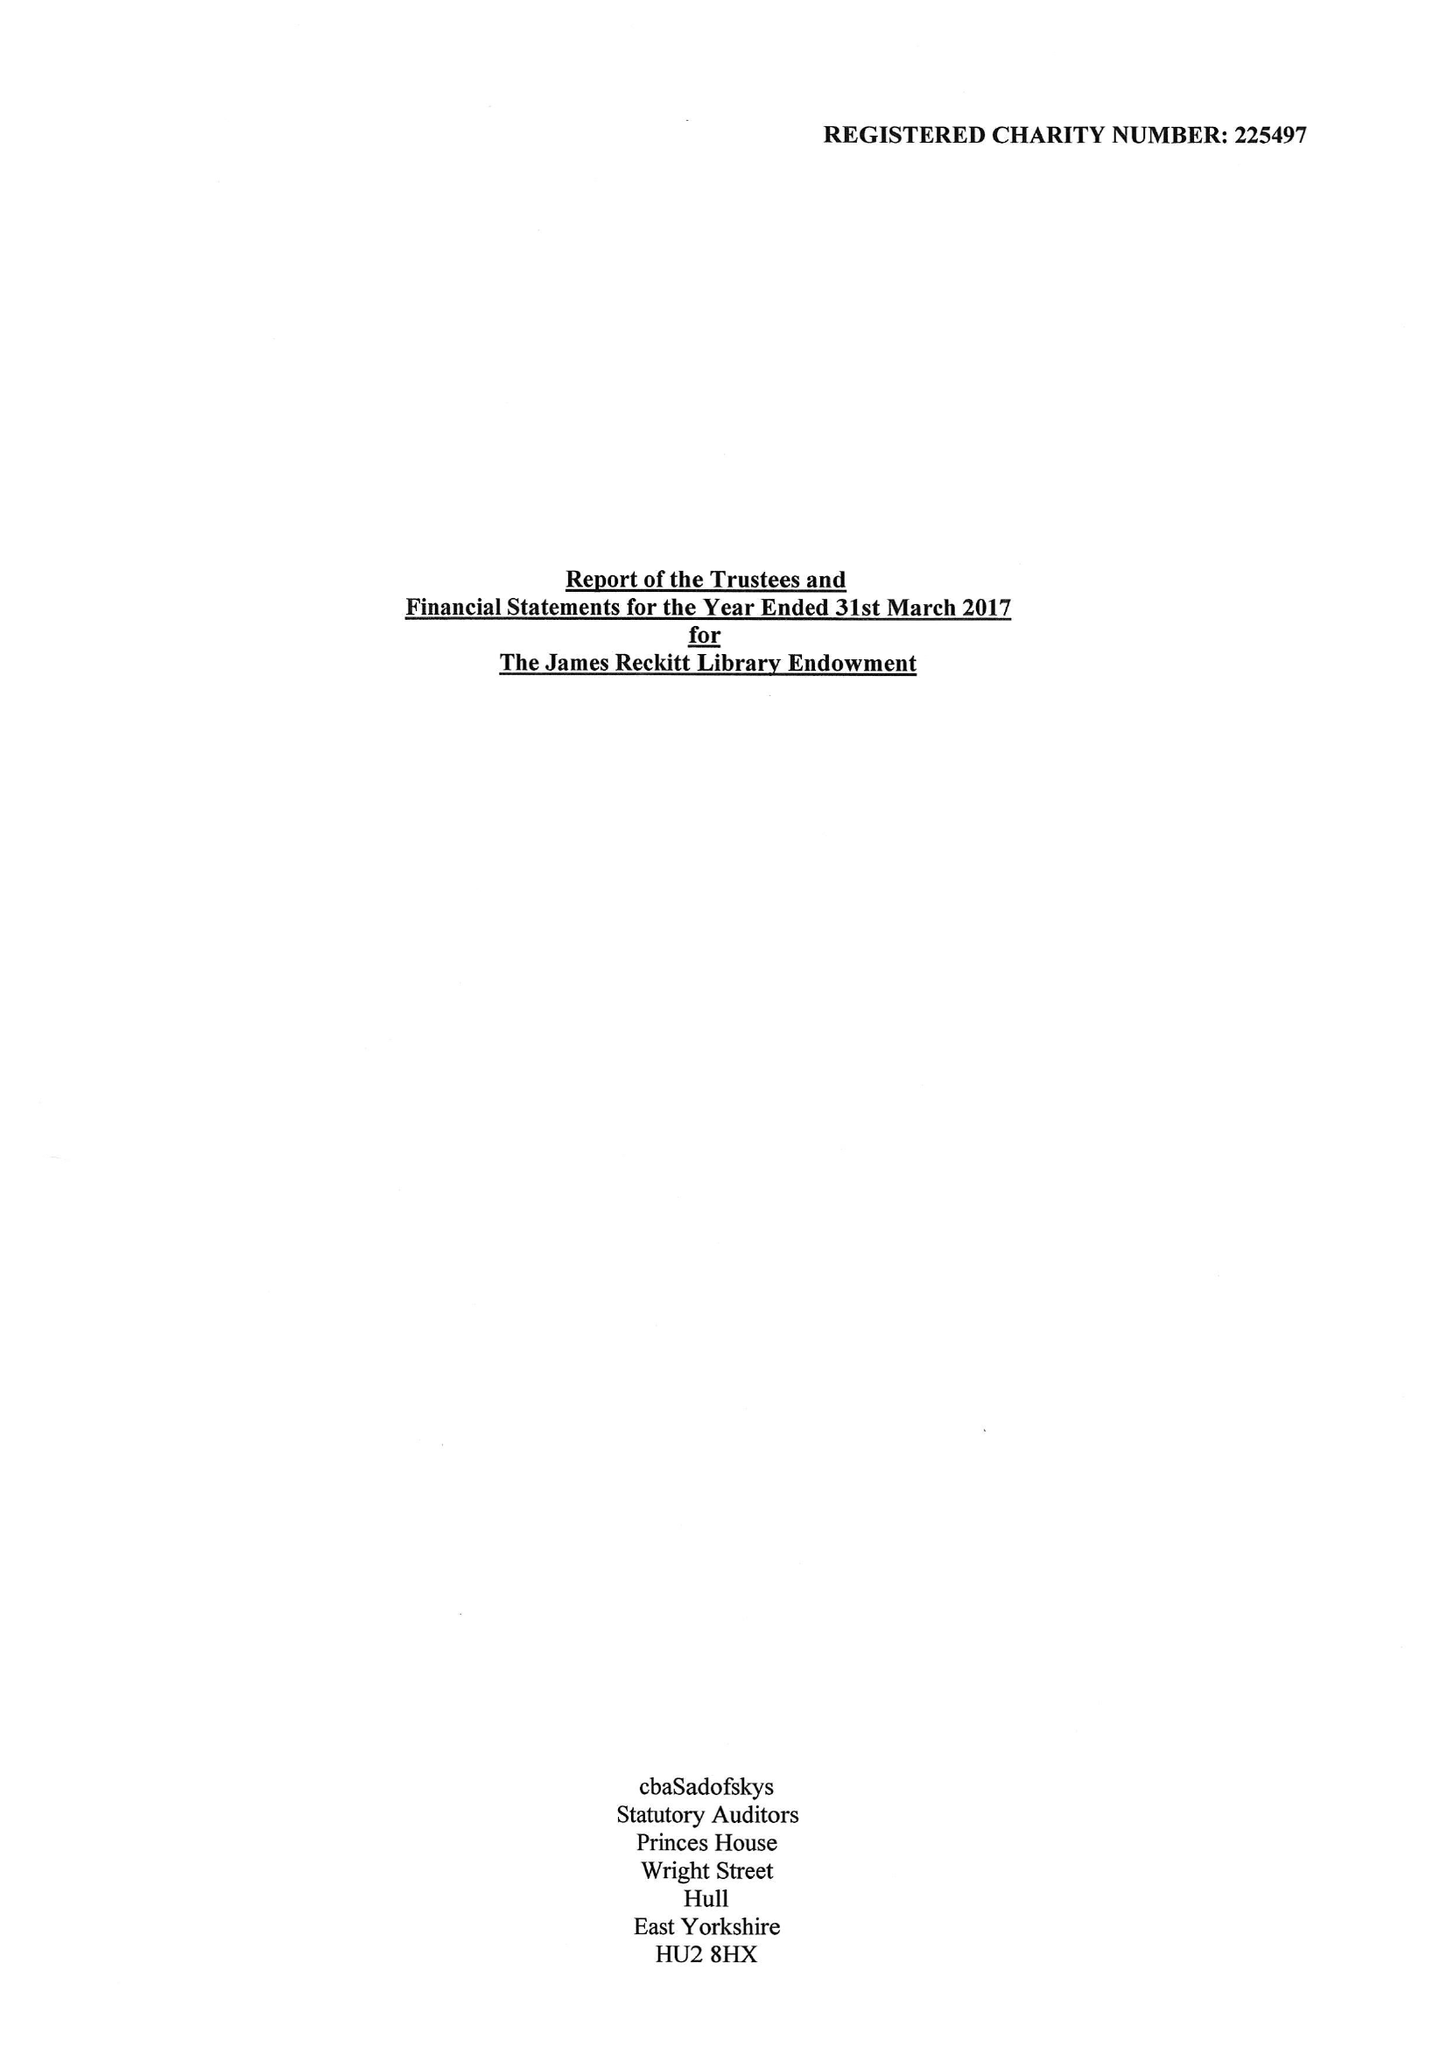What is the value for the charity_number?
Answer the question using a single word or phrase. 225497 